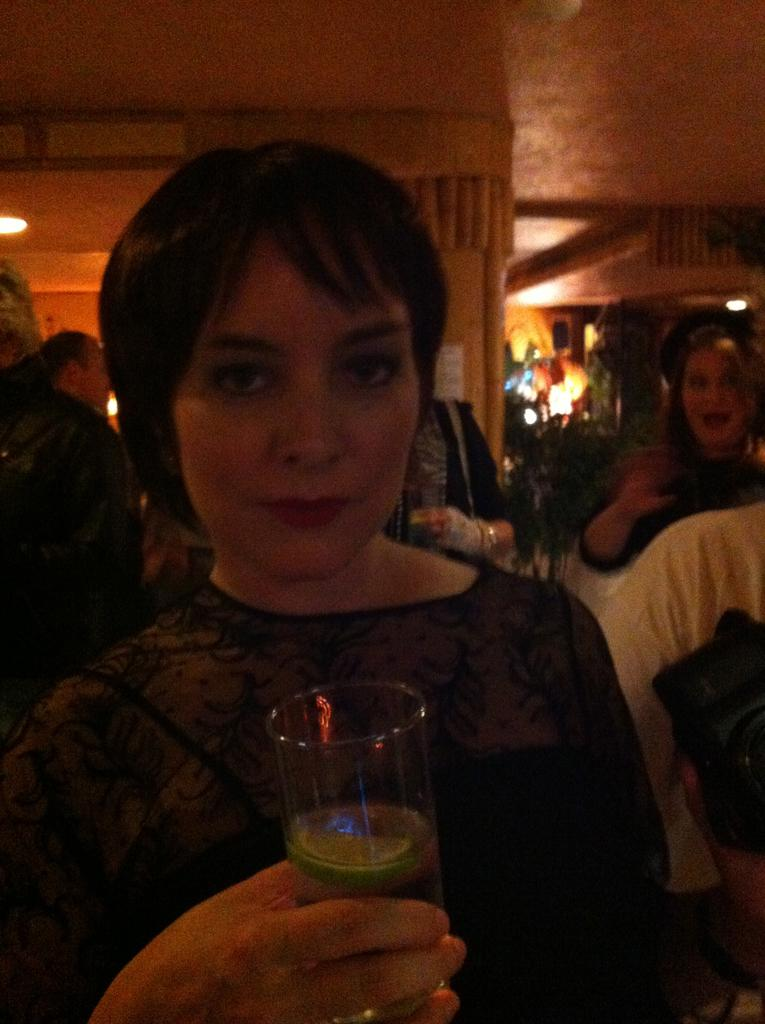Who is the main subject in the image? There is a woman in the image. What is the woman wearing? The woman is wearing a black dress. What is the woman holding in her hand? The woman is holding a glass in her hand. What can be seen in the background of the image? There are other people and lights visible in the background, and the ceiling is also visible. What type of scent can be detected coming from the woman's dress in the image? There is no information about the scent of the woman's dress in the image, so it cannot be determined. 